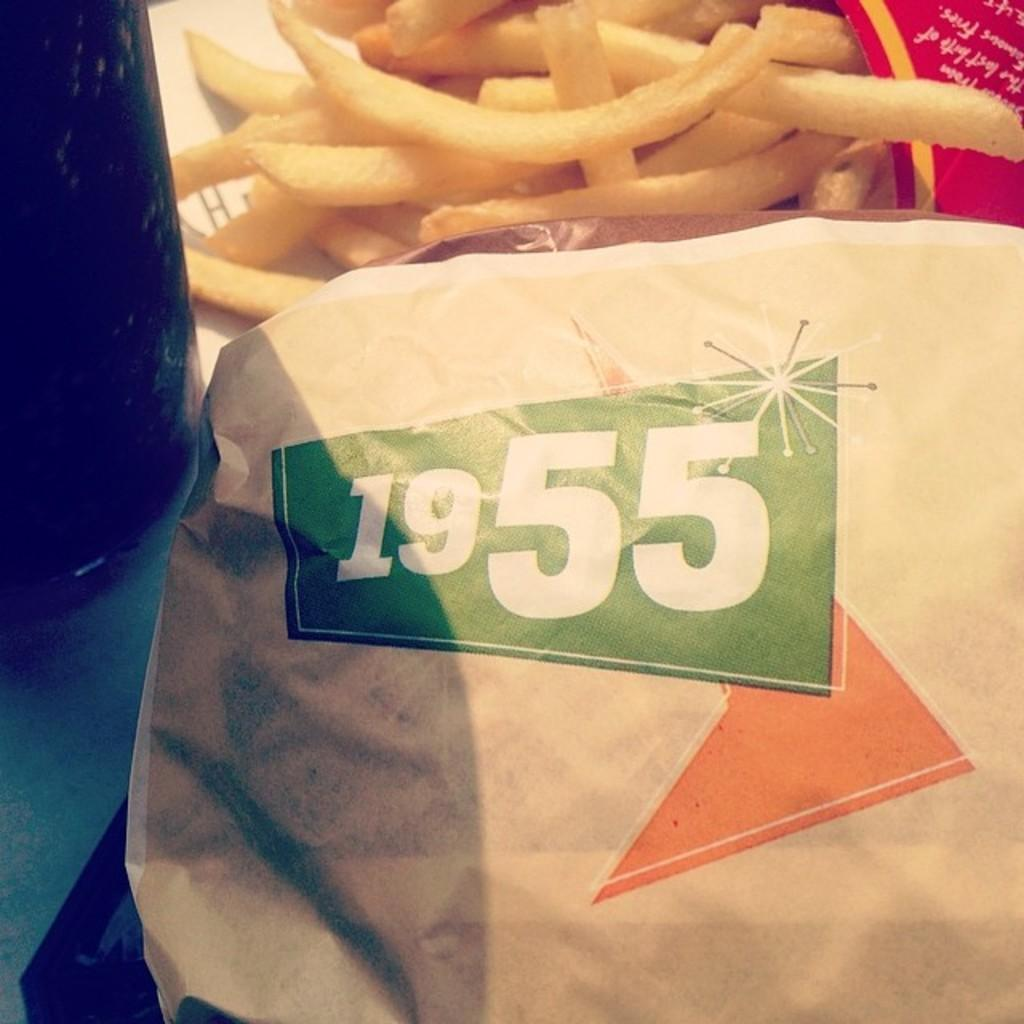What type of object can be seen in the image that is typically used for writing or drawing? There is paper in the image that is typically used for writing or drawing. What type of beverage container is visible in the image? There is a beverage bottle in the image. What type of food is present in the image? There are french fries in the image. On what surface are all the items placed in the image? All items are placed on a table. How many trains can be seen in the image? There are no trains present in the image. What type of doll is sitting on the table in the image? There is no doll present in the image. 